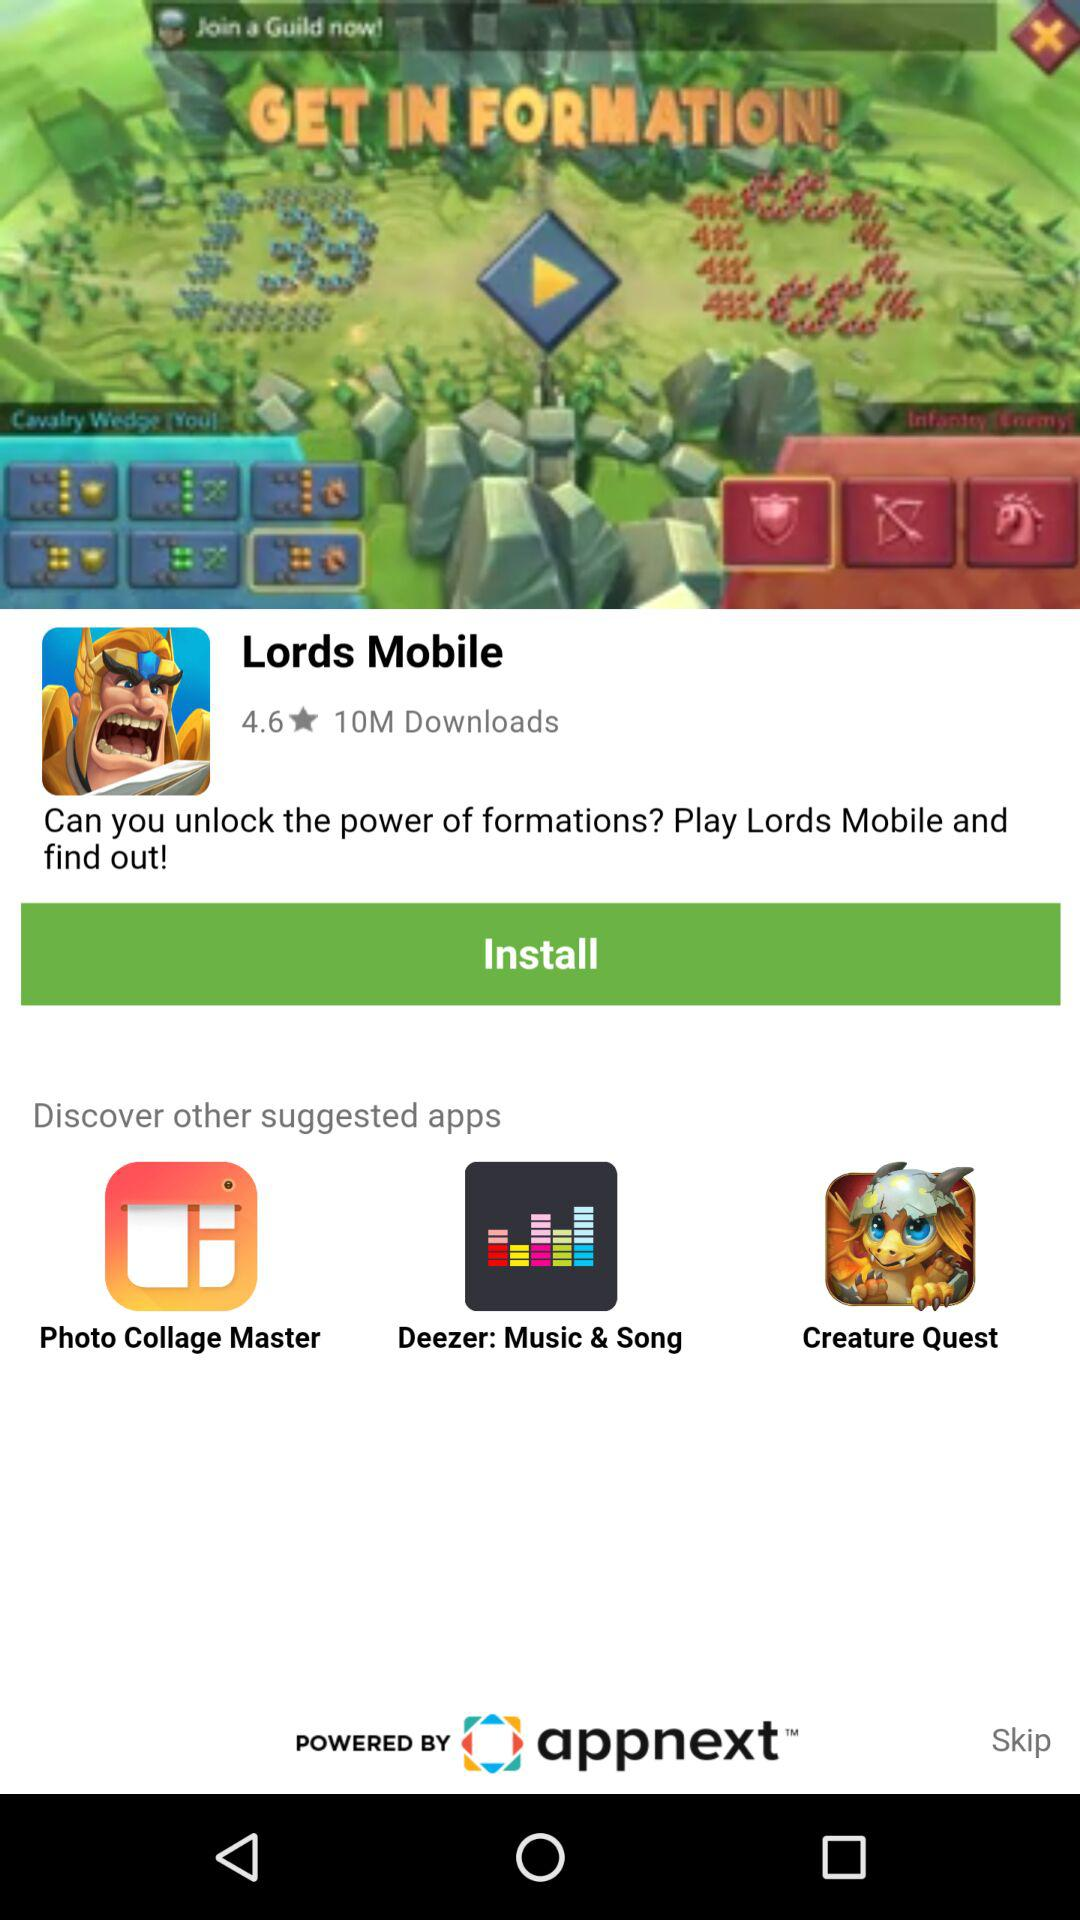How many people have downloaded "Lords Mobile"? There are 10 million people who have downloaded "Lords Mobile". 